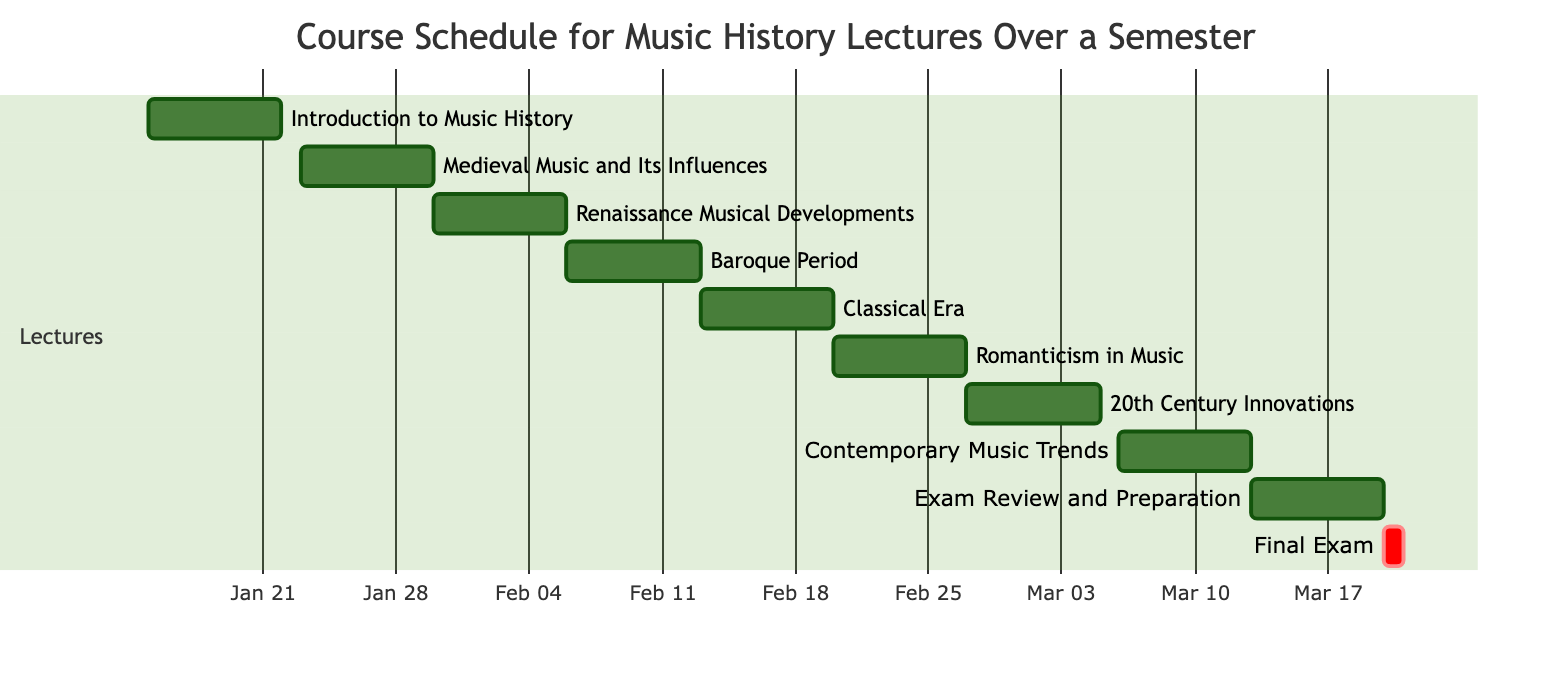What is the duration of the "Introduction to Music History" topic? The duration is determined by the start date, January 15, 2024, and the end date, January 22, 2024; this spans one week.
Answer: 1 week Which topic follows "Romanticism in Music"? By observing the timeline, "20th Century Innovations" starts immediately after "Romanticism in Music," which ends on February 26, 2024.
Answer: 20th Century Innovations How many total topics are covered in the course schedule? Counting the individual topics listed in the Gantt chart, there are ten distinct topics provided.
Answer: 10 What is the start date of the "Final Exam"? The Gantt chart shows that the "Final Exam" is scheduled for March 20, 2024.
Answer: March 20, 2024 Which week covers "Baroque Period: Key Composers"? By looking at the start date of "Baroque Period: Key Composers," which begins on February 6, 2024, and spans one week, this week is from February 6 to February 12, 2024.
Answer: February 6 - February 12, 2024 What is the relationship between "Exam Review and Preparation" and "Final Exam"? The "Exam Review and Preparation" topic ends on March 19, 2024, and the "Final Exam" starts the next day, creating a direct link where preparation leads into the final examination.
Answer: Continuous Does "Medieval Music and Its Influences" start before "Renaissance Musical Developments"? The start date of "Medieval Music and Its Influences" is January 23, 2024, which is before the start date of "Renaissance Musical Developments," on January 30, 2024.
Answer: Yes Which topic has the longest continuous period without any gaps? Analyzing the schedule, each topic occurs consecutively for one week without any breaks; therefore, all topics share the same duration.
Answer: All topics On what day does the course schedule officially begin? The earliest start date in the schedule is January 15, 2024, marking the official start of the course.
Answer: January 15, 2024 